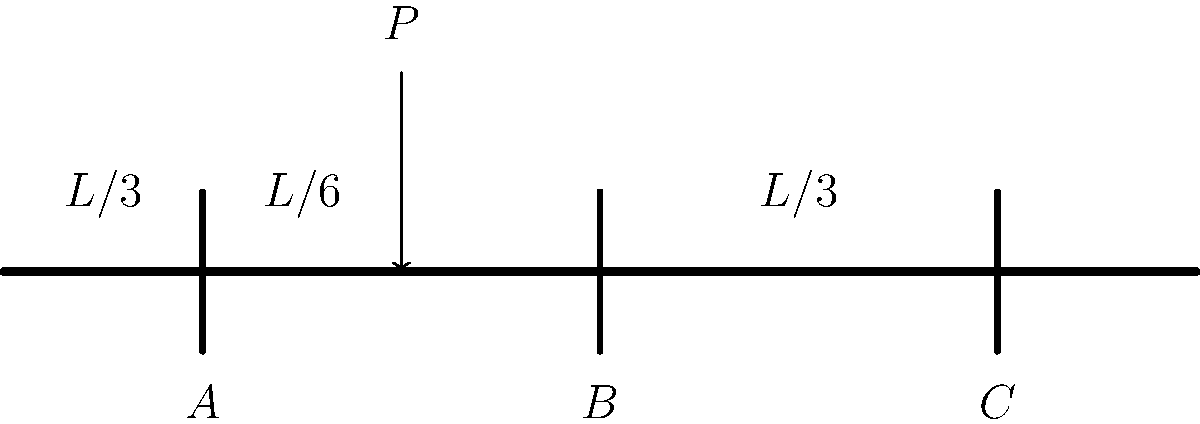A continuous beam ABC with three equally spaced supports is subjected to a point load $P$ at a distance $L/6$ from support A, where $L$ is the total length of the beam. Considering the concept of moment distribution, which support is likely to experience the highest reaction force? Explain your reasoning, taking into account how your different alters might approach this problem. Let's approach this step-by-step, considering how different perspectives (alters) might analyze the problem:

1) First, let's consider the geometry:
   - The beam has three supports (A, B, and C) equally spaced at $L/3$ intervals.
   - The load $P$ is applied at $L/6$ from support A.

2) From a structural analysis perspective:
   - The load is closer to support A than to the other supports.
   - However, the continuous nature of the beam allows for load distribution.

3) Considering moment distribution:
   - The load will create a larger moment at support B than at A or C.
   - This is because B is the closest interior support to the load.

4) From an intuitive perspective:
   - One might think support A would have the highest reaction due to its proximity to the load.
   - However, the continuity of the beam allows for better load distribution.

5) Using engineering judgment:
   - The reaction at B will likely be the highest due to its ability to resist moment in both directions.
   - Supports A and C will share the load, but to a lesser extent than B.

6) Considering the integration of multiple perspectives:
   - It's valuable to recognize that different alters might approach this problem differently.
   - Some might rely more on intuition, others on mathematical analysis.
   - Integrating these perspectives leads to a more comprehensive understanding.

Ultimately, the highest reaction force is most likely to occur at support B due to its central position and ability to resist moment in both directions, despite the load being closer to support A.
Answer: Support B 